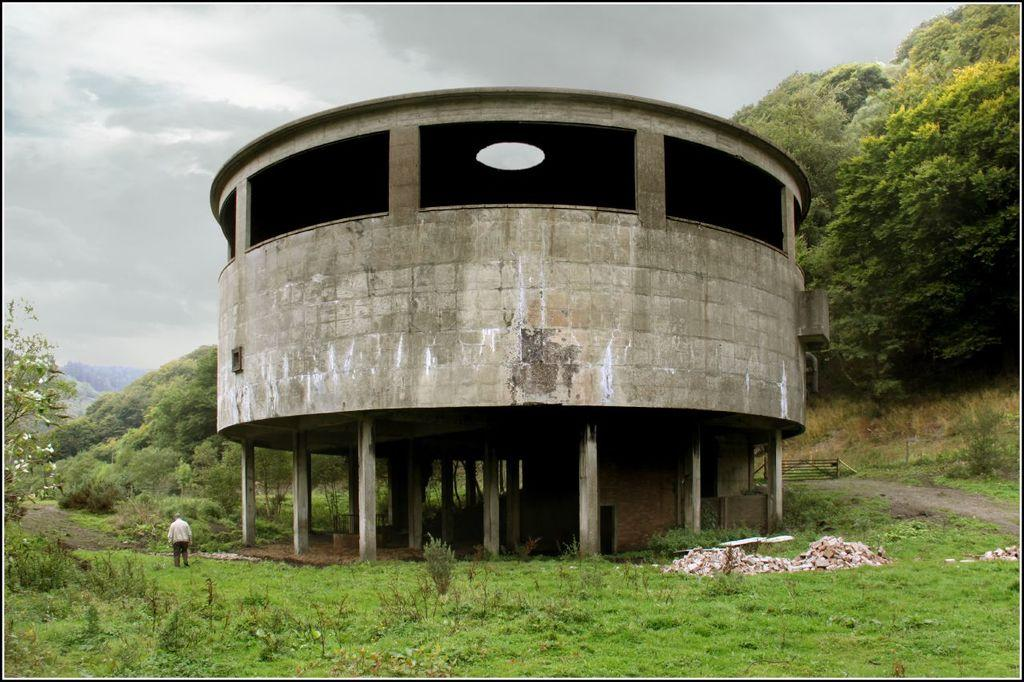What is the main structure in the center of the image? There is a fort in the center of the image. Can you describe the person in the image? There is a person standing in the image. What can be seen in the background of the image? There are trees in the background of the image. What type of vegetation is at the bottom of the image? There are plants at the bottom of the image. What is present on the ground in the image? Stones are present on the ground. Can you hear the boat start in the image? There is no boat present in the image, so it is not possible to hear it start. 